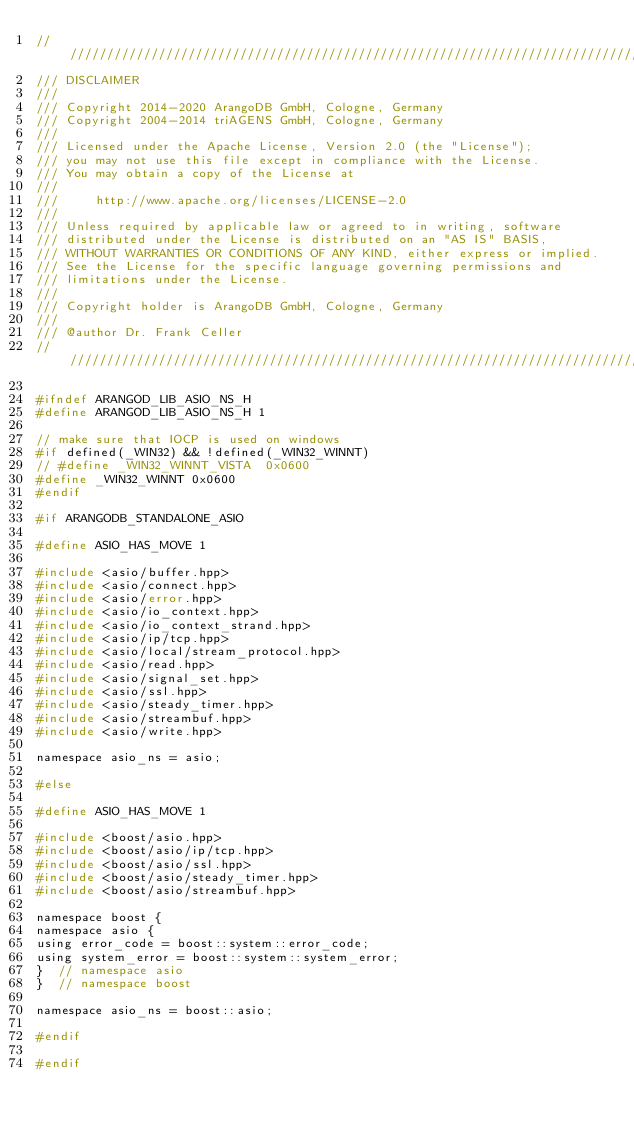<code> <loc_0><loc_0><loc_500><loc_500><_C_>////////////////////////////////////////////////////////////////////////////////
/// DISCLAIMER
///
/// Copyright 2014-2020 ArangoDB GmbH, Cologne, Germany
/// Copyright 2004-2014 triAGENS GmbH, Cologne, Germany
///
/// Licensed under the Apache License, Version 2.0 (the "License");
/// you may not use this file except in compliance with the License.
/// You may obtain a copy of the License at
///
///     http://www.apache.org/licenses/LICENSE-2.0
///
/// Unless required by applicable law or agreed to in writing, software
/// distributed under the License is distributed on an "AS IS" BASIS,
/// WITHOUT WARRANTIES OR CONDITIONS OF ANY KIND, either express or implied.
/// See the License for the specific language governing permissions and
/// limitations under the License.
///
/// Copyright holder is ArangoDB GmbH, Cologne, Germany
///
/// @author Dr. Frank Celler
////////////////////////////////////////////////////////////////////////////////

#ifndef ARANGOD_LIB_ASIO_NS_H
#define ARANGOD_LIB_ASIO_NS_H 1

// make sure that IOCP is used on windows
#if defined(_WIN32) && !defined(_WIN32_WINNT)
// #define _WIN32_WINNT_VISTA  0x0600
#define _WIN32_WINNT 0x0600
#endif

#if ARANGODB_STANDALONE_ASIO

#define ASIO_HAS_MOVE 1

#include <asio/buffer.hpp>
#include <asio/connect.hpp>
#include <asio/error.hpp>
#include <asio/io_context.hpp>
#include <asio/io_context_strand.hpp>
#include <asio/ip/tcp.hpp>
#include <asio/local/stream_protocol.hpp>
#include <asio/read.hpp>
#include <asio/signal_set.hpp>
#include <asio/ssl.hpp>
#include <asio/steady_timer.hpp>
#include <asio/streambuf.hpp>
#include <asio/write.hpp>

namespace asio_ns = asio;

#else

#define ASIO_HAS_MOVE 1

#include <boost/asio.hpp>
#include <boost/asio/ip/tcp.hpp>
#include <boost/asio/ssl.hpp>
#include <boost/asio/steady_timer.hpp>
#include <boost/asio/streambuf.hpp>

namespace boost {
namespace asio {
using error_code = boost::system::error_code;
using system_error = boost::system::system_error;
}  // namespace asio
}  // namespace boost

namespace asio_ns = boost::asio;

#endif

#endif
</code> 